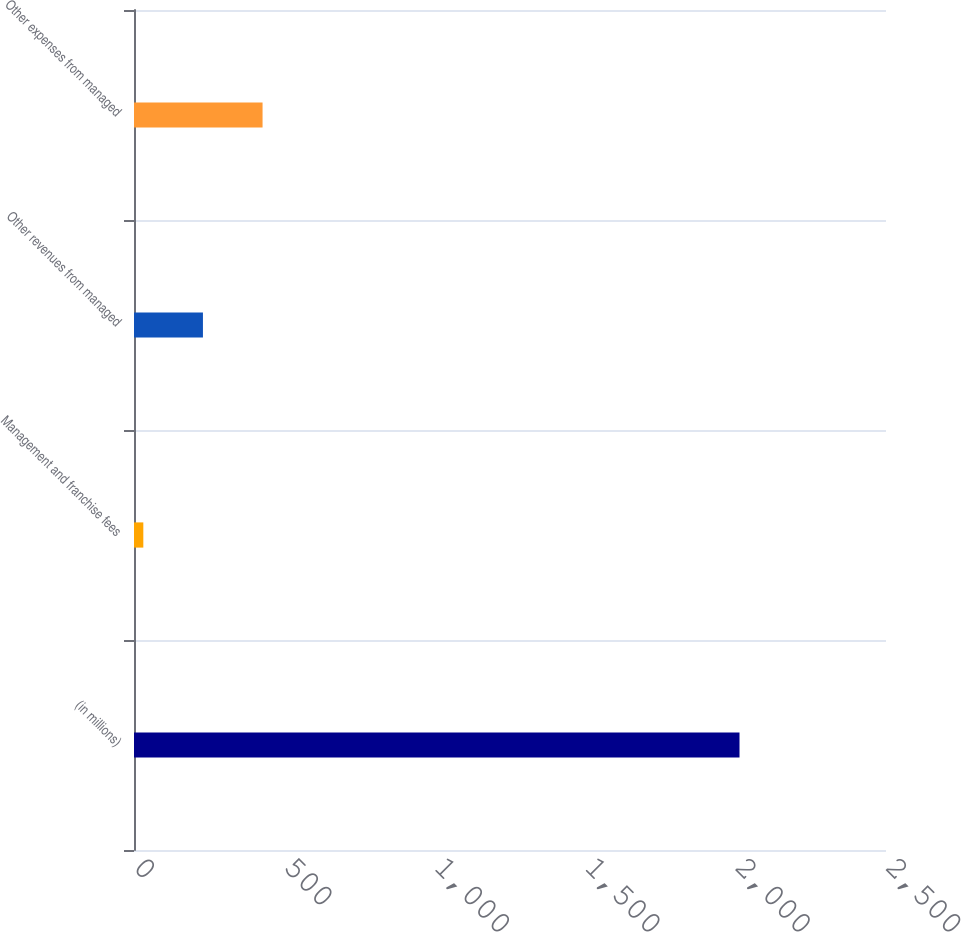Convert chart. <chart><loc_0><loc_0><loc_500><loc_500><bar_chart><fcel>(in millions)<fcel>Management and franchise fees<fcel>Other revenues from managed<fcel>Other expenses from managed<nl><fcel>2013<fcel>31<fcel>229.2<fcel>427.4<nl></chart> 